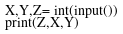Convert code to text. <code><loc_0><loc_0><loc_500><loc_500><_Python_>X,Y,Z= int(input())
print(Z,X,Y)</code> 